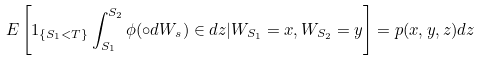Convert formula to latex. <formula><loc_0><loc_0><loc_500><loc_500>E \left [ 1 _ { \{ S _ { 1 } < T \} } \int _ { S _ { 1 } } ^ { S _ { 2 } } \phi ( \circ d W _ { s } ) \in d z | W _ { S _ { 1 } } = x , W _ { S _ { 2 } } = y \right ] = p ( x , y , z ) d z</formula> 